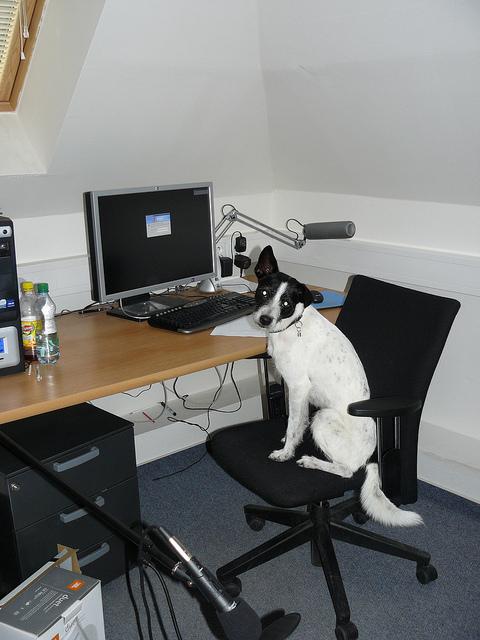What is the dog sitting on?
Be succinct. Chair. Who is taking the picture?
Give a very brief answer. Person. What breed of dog is this?
Short answer required. Terrier. What type of office chair is in this picture?
Quick response, please. Black. Is the dog under the desk or on top of the desk?
Give a very brief answer. Top. Is the dog laying in a dog bed?
Answer briefly. No. What are the wires on the wall for?
Write a very short answer. Computer. Is the floor a wood floor?
Write a very short answer. No. Is the chair a mid or high back chair?
Be succinct. Mid. What type of activity is the dog most likely waiting to participating in?
Give a very brief answer. Walk. How many coffee cups can you see?
Give a very brief answer. 0. Who is sitting at the desk?
Answer briefly. Dog. What kind of animal is this?
Write a very short answer. Dog. Is the monitor on?
Write a very short answer. Yes. Is the monitor on?
Be succinct. Yes. 